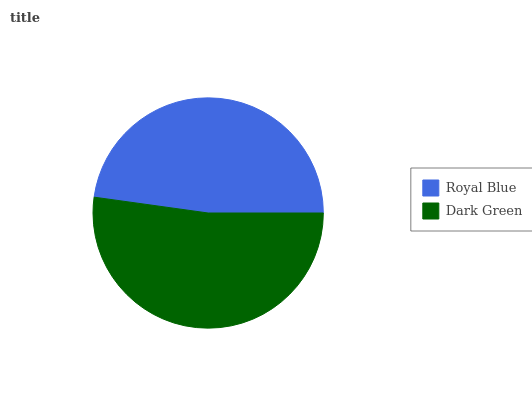Is Royal Blue the minimum?
Answer yes or no. Yes. Is Dark Green the maximum?
Answer yes or no. Yes. Is Dark Green the minimum?
Answer yes or no. No. Is Dark Green greater than Royal Blue?
Answer yes or no. Yes. Is Royal Blue less than Dark Green?
Answer yes or no. Yes. Is Royal Blue greater than Dark Green?
Answer yes or no. No. Is Dark Green less than Royal Blue?
Answer yes or no. No. Is Dark Green the high median?
Answer yes or no. Yes. Is Royal Blue the low median?
Answer yes or no. Yes. Is Royal Blue the high median?
Answer yes or no. No. Is Dark Green the low median?
Answer yes or no. No. 